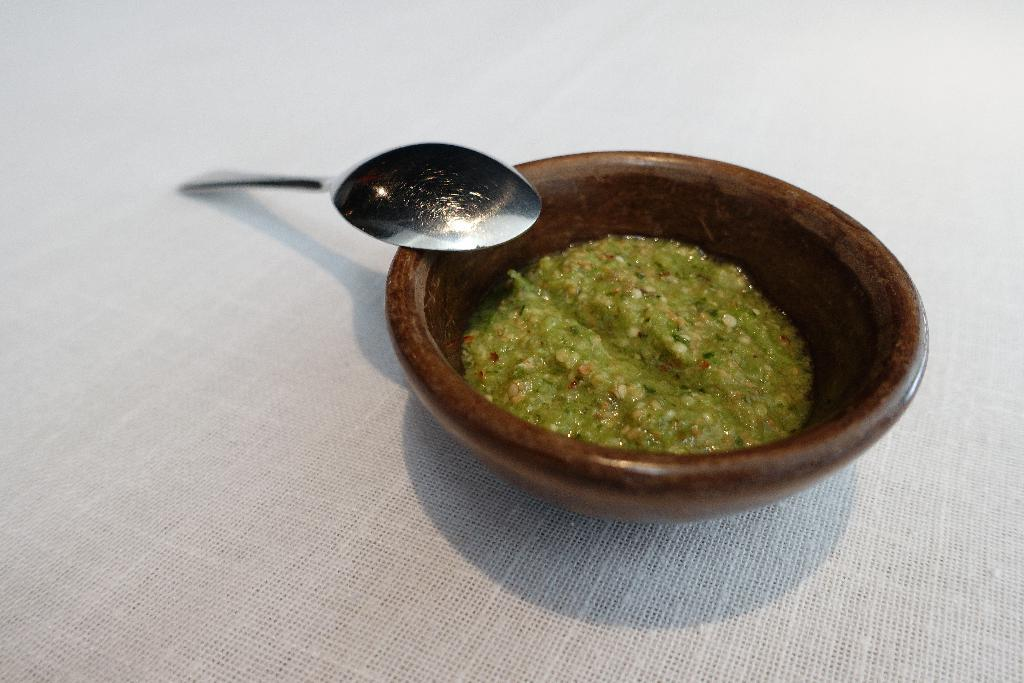What is at the bottom of the image? There is a white cloth at the bottom of the image. What is in the middle of the image? There is a bowl with a food item in the middle of the image. What utensil is associated with the bowl? There is a spoon associated with the bowl. Can you hear a whistle in the image? There is no mention of a whistle in the image, so it cannot be heard. Is there a group of people flying a kite in the image? There is no mention of a group of people or a kite in the image. 